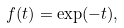<formula> <loc_0><loc_0><loc_500><loc_500>f ( t ) = \exp ( - t ) ,</formula> 